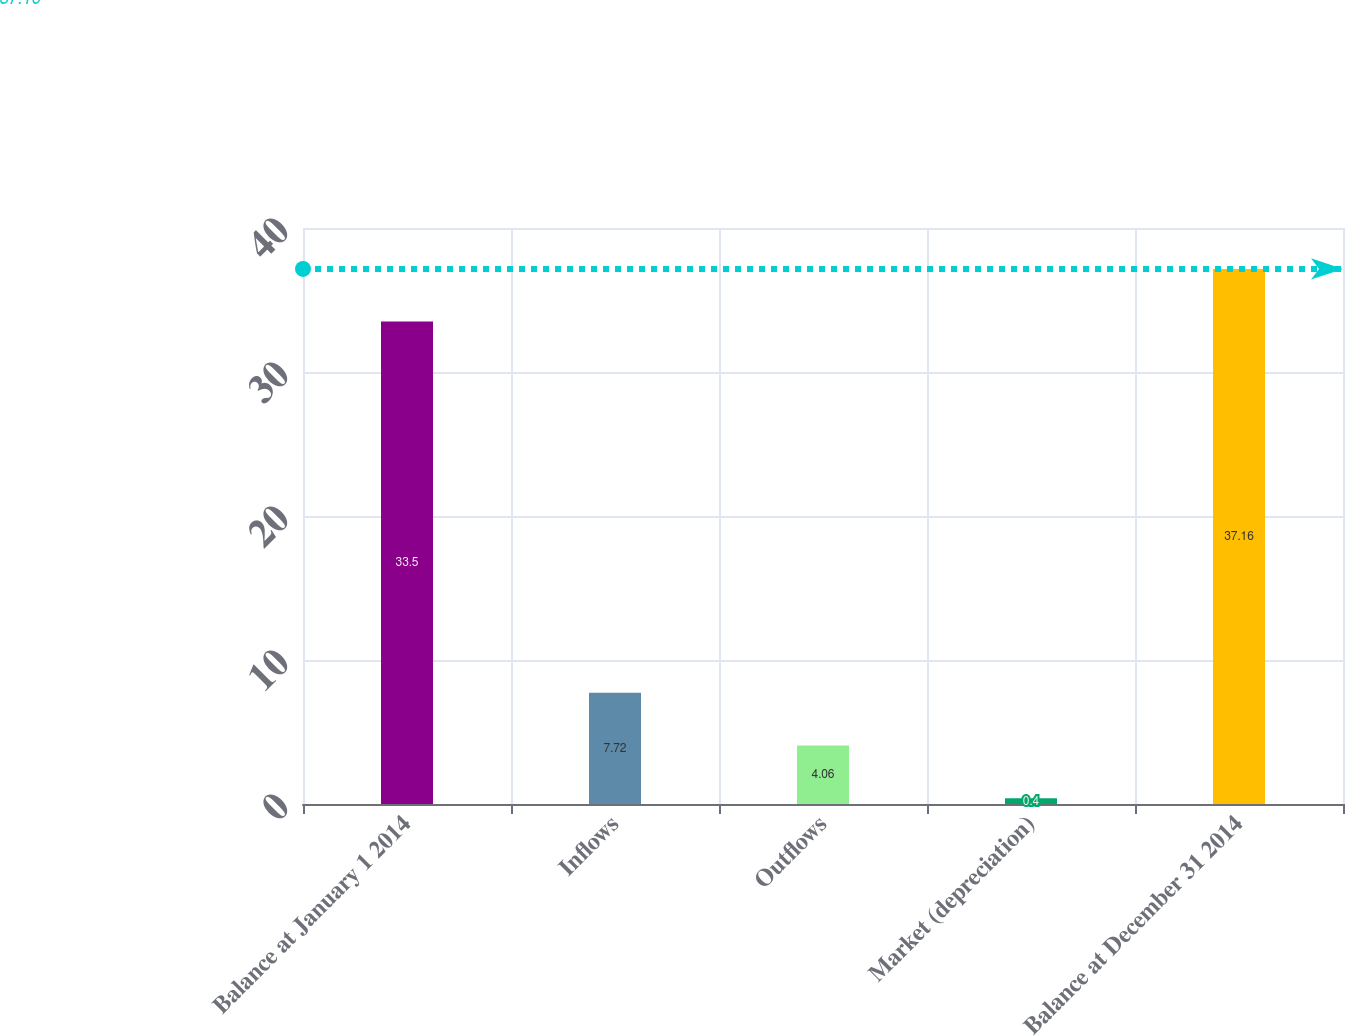Convert chart to OTSL. <chart><loc_0><loc_0><loc_500><loc_500><bar_chart><fcel>Balance at January 1 2014<fcel>Inflows<fcel>Outflows<fcel>Market (depreciation)<fcel>Balance at December 31 2014<nl><fcel>33.5<fcel>7.72<fcel>4.06<fcel>0.4<fcel>37.16<nl></chart> 